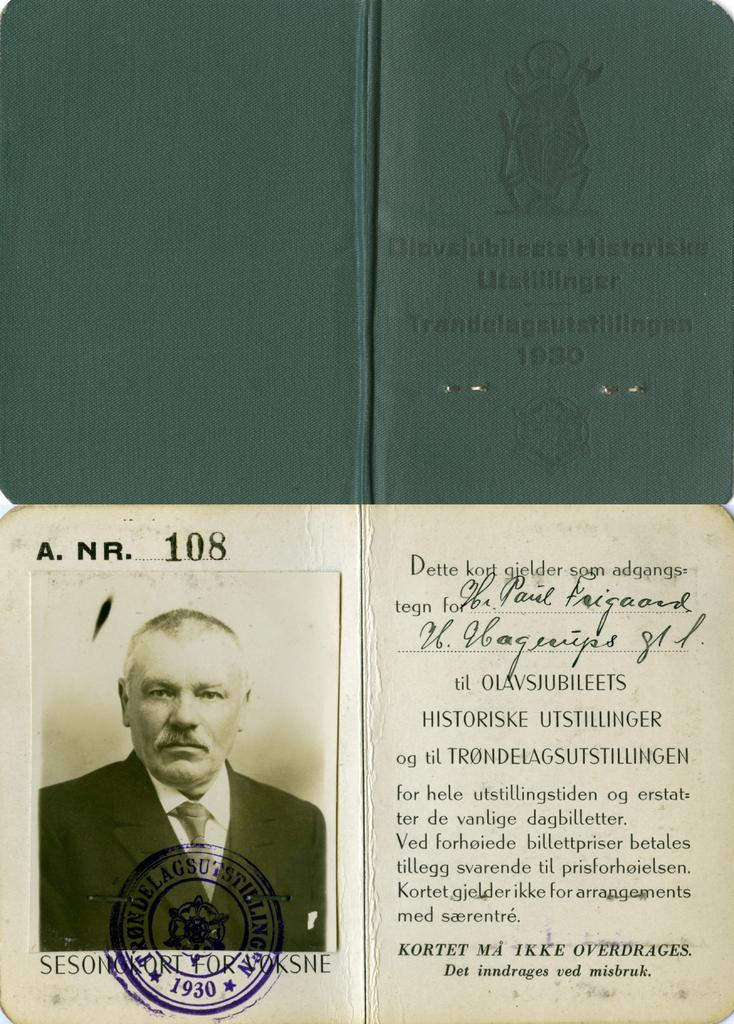<image>
Render a clear and concise summary of the photo. A small booklet is shown closed and opened to a page with the number 108 on it. 